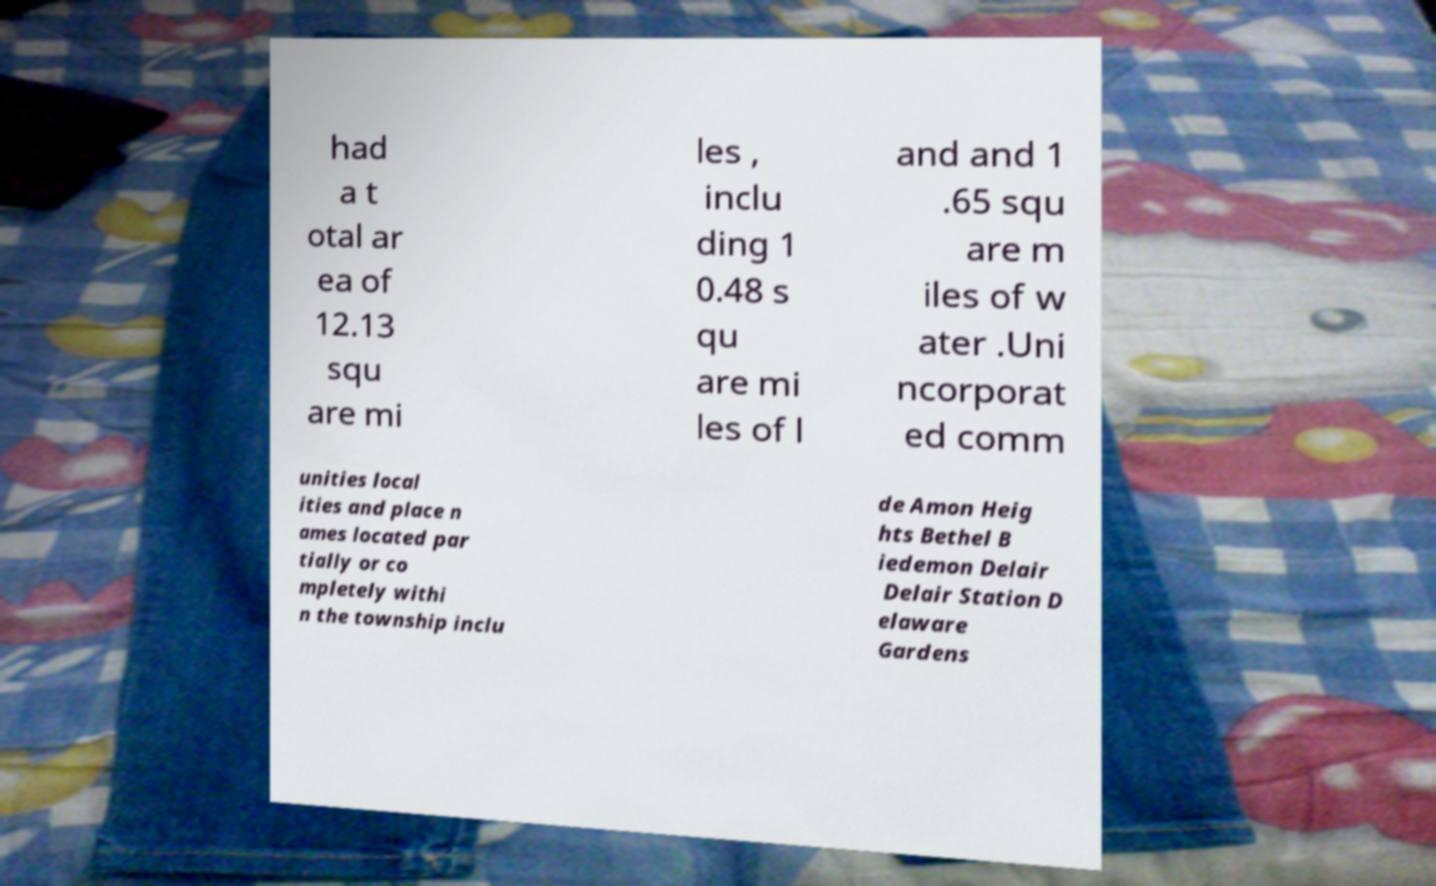Could you extract and type out the text from this image? had a t otal ar ea of 12.13 squ are mi les , inclu ding 1 0.48 s qu are mi les of l and and 1 .65 squ are m iles of w ater .Uni ncorporat ed comm unities local ities and place n ames located par tially or co mpletely withi n the township inclu de Amon Heig hts Bethel B iedemon Delair Delair Station D elaware Gardens 